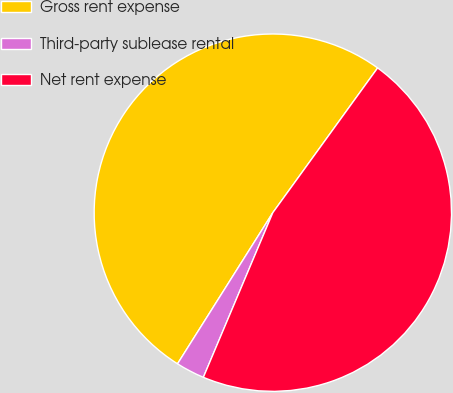Convert chart to OTSL. <chart><loc_0><loc_0><loc_500><loc_500><pie_chart><fcel>Gross rent expense<fcel>Third-party sublease rental<fcel>Net rent expense<nl><fcel>51.02%<fcel>2.6%<fcel>46.38%<nl></chart> 